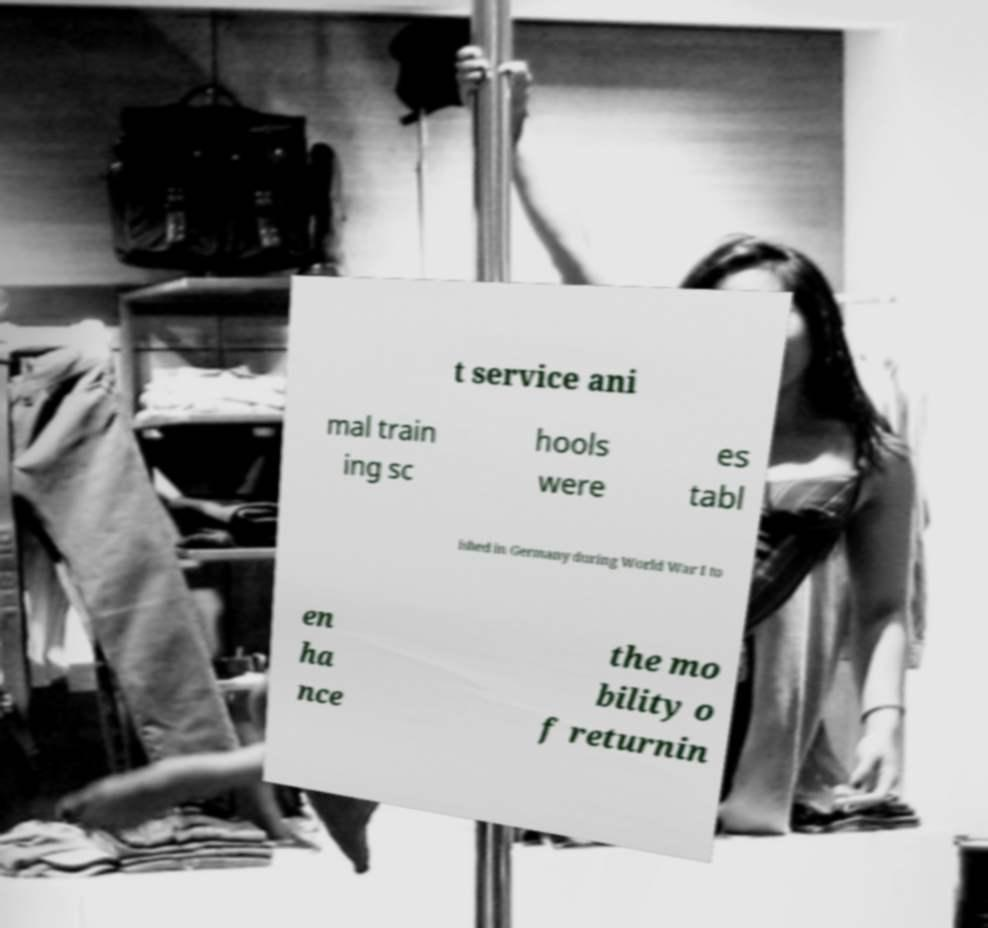Could you assist in decoding the text presented in this image and type it out clearly? t service ani mal train ing sc hools were es tabl ished in Germany during World War I to en ha nce the mo bility o f returnin 